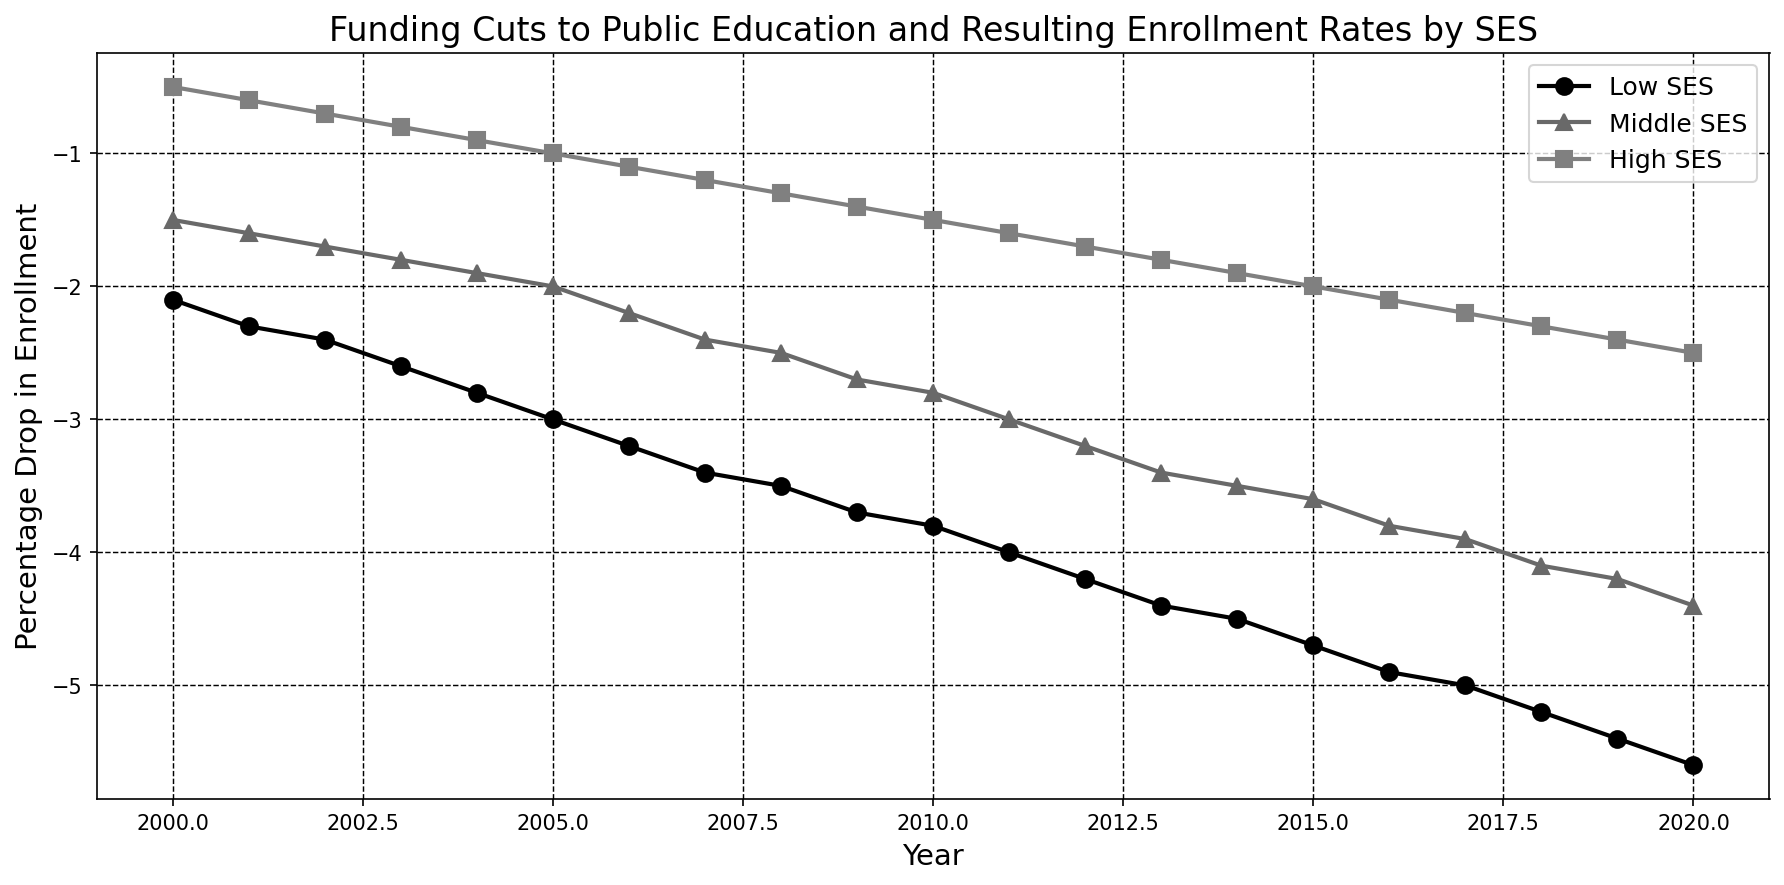What was the percentage drop in enrollment for Low SES in 2010? Look at the point on the line for Low SES corresponding to the year 2010. The value on the y-axis at this point shows the percentage drop in enrollment. For Low SES in 2010, it was -3.8%
Answer: -3.8% Which SES category experienced the largest overall drop in enrollment from 2000 to 2020? Compare the values for Low SES, Middle SES, and High SES from 2000 to 2020. Calculate the difference between the starting and ending values for each category. The Low SES group saw a drop from -2.1% to -5.6%, the largest overall drop.
Answer: Low SES How much greater was the drop in enrollment rates for Middle SES compared to High SES in 2020? Look at the enrollment drop percentages for both Middle SES and High SES in 2020. Subtract the drop in High SES from the drop in Middle SES (-4.4% - (-2.5%) = -4.4% + 2.5% = -1.9%).
Answer: -1.9% What was the average drop in enrollment for High SES from 2010 to 2020? To find the average drop, sum up the enrollment drops for High SES from 2010 to 2020 and divide by the number of years (11). Sum of drops = (-1.5) + (-1.6) + (-1.7) + (-1.8) + (-1.9) + (-2.0) + (-2.1) + (-2.2) + (-2.3) + (-2.4) + (-2.5) = -21.0. Average is -21.0 / 11 = -1.91.
Answer: -1.91% In which year did the Middle SES category first reach a drop of -3.0% or more? Look at the years on the x-axis and check the corresponding values for Middle SES. The first year it reached -3.0% was 2011.
Answer: 2011 Between 2009 and 2013, which SES category had the smallest increase in enrollment drop? Calculate the change in enrollment drop for each category between 2009 and 2013. Low SES: -4.4 - (-3.7) = -0.7. Middle SES: -3.4 - (-2.7) = -0.7. High SES: -1.8 - (-1.4) = -0.4. High SES had the smallest increase (-0.4).
Answer: High SES How does the overall trend in enrollment drop for Low SES compare to High SES over the entire period? Observe the general direction and steepness of the lines for Low SES and High SES from 2000 to 2020. Low SES shows a steeper and more significant drop compared to High SES, indicating a sharper decline over time.
Answer: Low SES has a steeper decline Which SES category's enrollment drop line is the darkest in the plot? Notice the colors of the lines representing each SES category. The darkest line corresponds to Low SES.
Answer: Low SES 